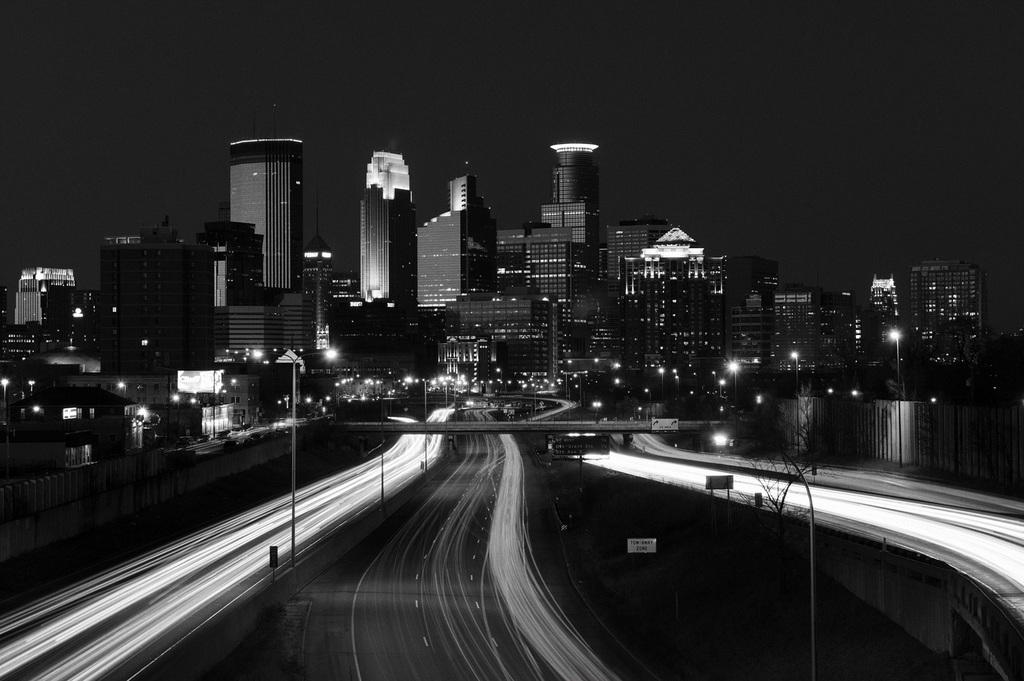What is the color scheme of the image? The image is black and white. What type of structures can be seen in the image? There are buildings in the image. What objects are present that emit light? There are lights in the image. What type of vertical structures are present in the image? There are poles in the image. What type of flat, rectangular objects are present in the image? There are boards in the image. What type of barrier can be seen in the image? There is a fence in the image. What type of pathway is visible in the image? There is a road in the image. Can you tell me how many strangers are standing near the station in the image? There is no station or strangers present in the image. What type of fire can be seen near the flame in the image? There is no flame present in the image. 